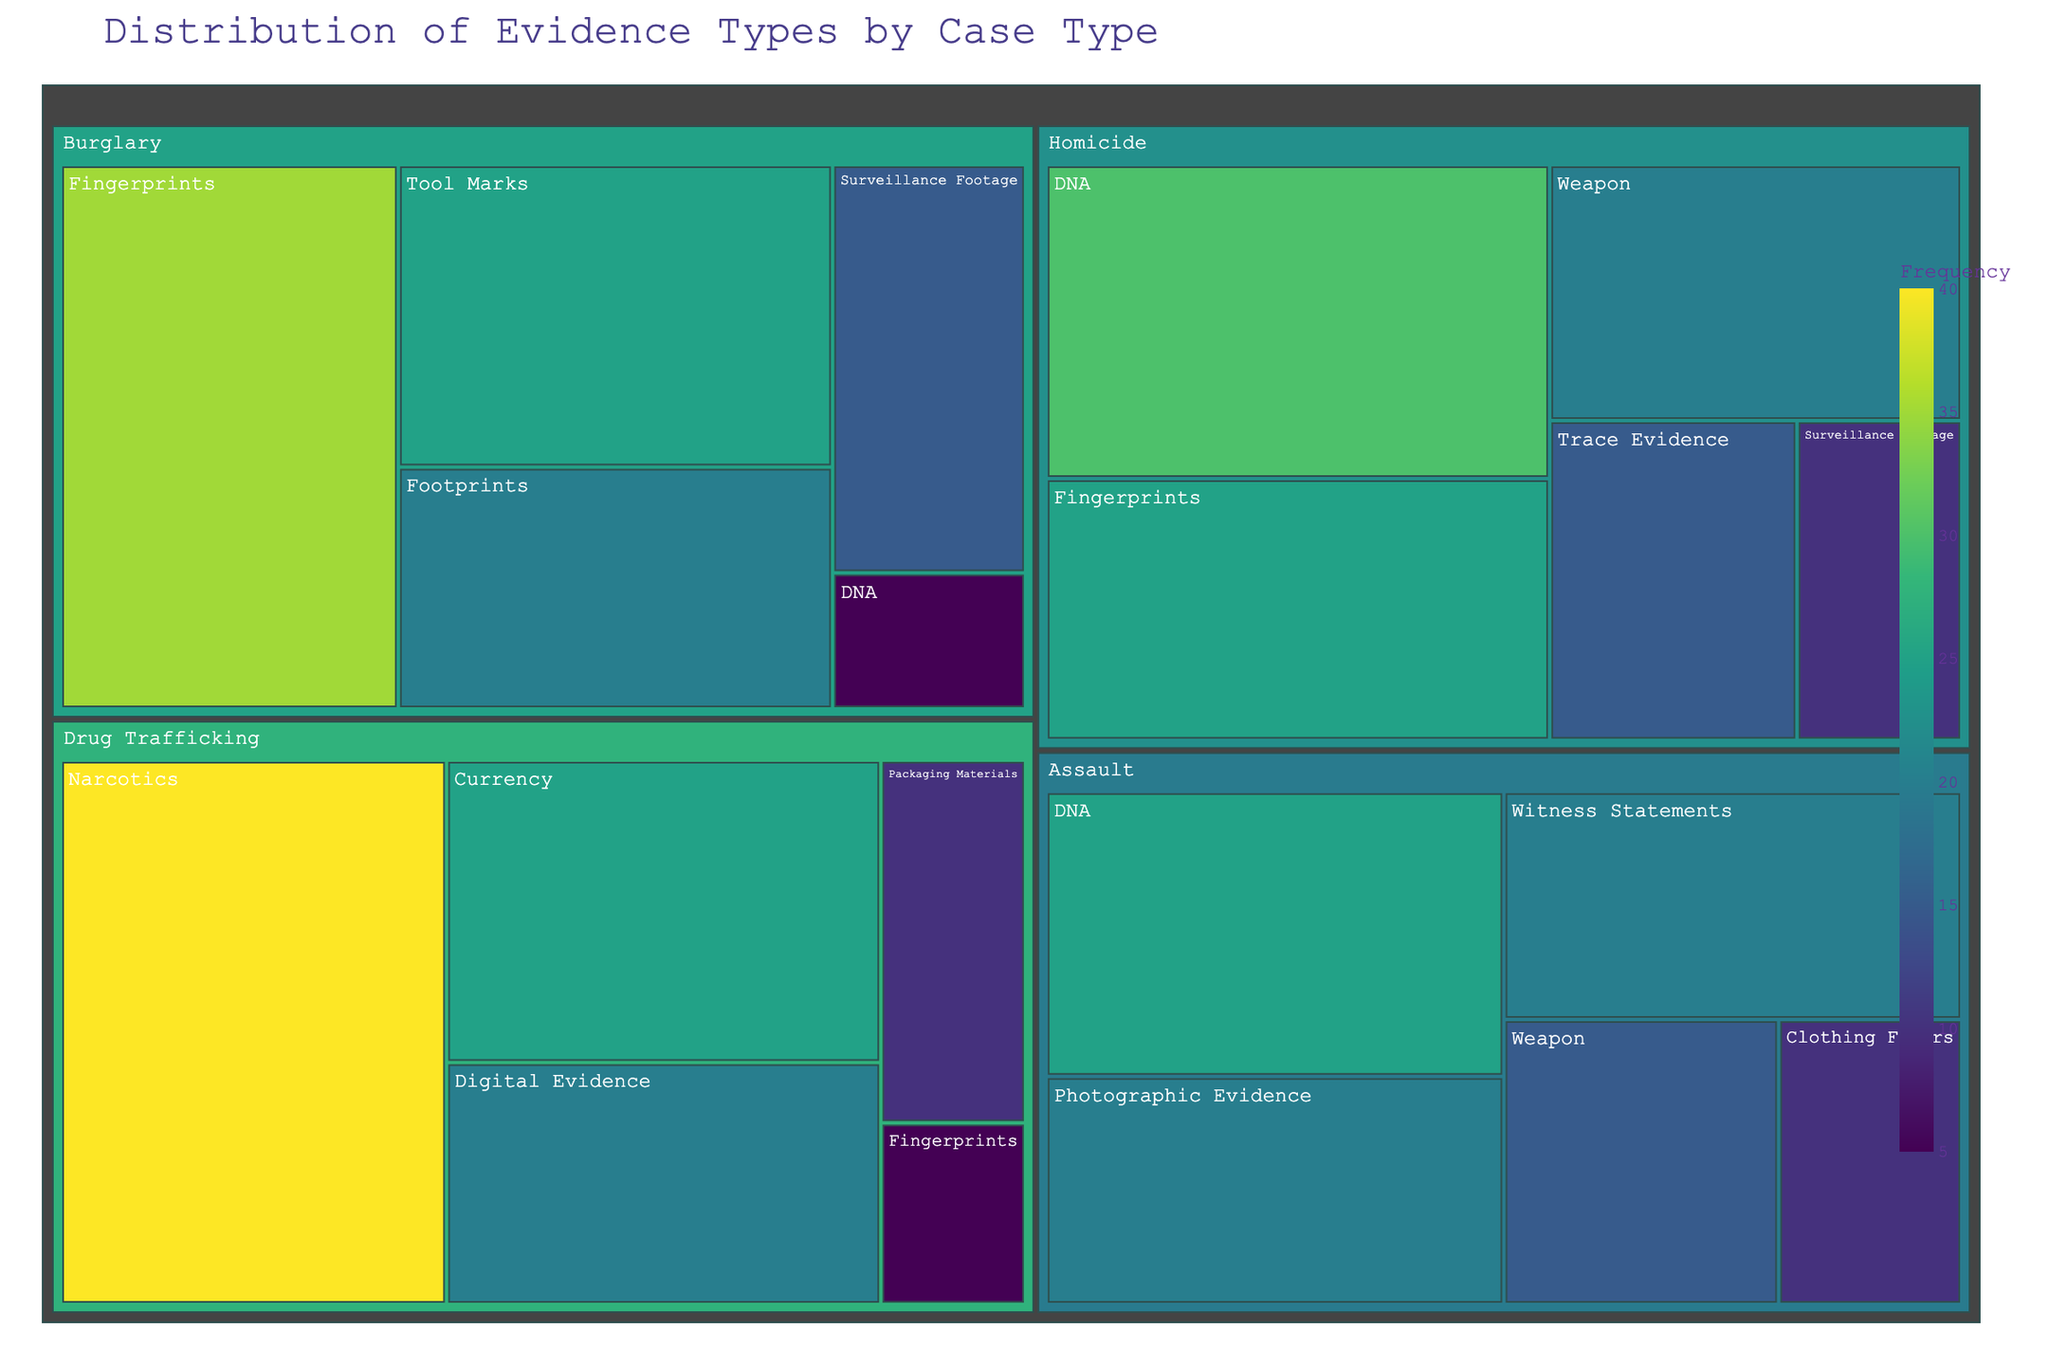What is the most collected type of evidence for Homicide cases? Look at the section under "Homicide" and identify the evidence type with the highest frequency.
Answer: DNA Which evidence type is least frequently collected for Burglary cases? Examine the segments under "Burglary" and locate the evidence type with the smallest portion.
Answer: DNA Compare the frequency of DNA evidence between Homicide and Assault cases. Which is higher? Observe the "DNA" sections under both "Homicide" and "Assault" and compare their sizes.
Answer: Homicide How does the frequency of Fingerprints in Burglary cases compare to Homicide cases? Check both "Fingerprints" under "Burglary" and "Homicide" and compare their frequencies.
Answer: Higher in Burglary What is the total frequency of Surveillance Footage evidence across all case types? Sum up the frequencies of "Surveillance Footage" under "Homicide" and "Burglary".
Answer: 25 Which case type has the most diverse types of evidence collected, based on the number of unique evidence types? Count the unique evidence types under each case type.
Answer: Drug Trafficking (5 types) For which case type is the frequency of Narcotics evidence the highest? Identify the segment where "Narcotics" exists and check its frequency.
Answer: Drug Trafficking What is the second most frequent evidence type for Assault cases? Identify the second-largest segment under "Assault".
Answer: Photographic Evidence and Witness Statements (tie) Does Digital Evidence appear in any case type other than Drug Trafficking? Look at all segments for each case type to see if "Digital Evidence" is present anywhere besides "Drug Trafficking".
Answer: No Which evidence type had a frequency of 10 in Homicide cases? Find the segment under "Homicide" with a frequency of 10.
Answer: Surveillance Footage 